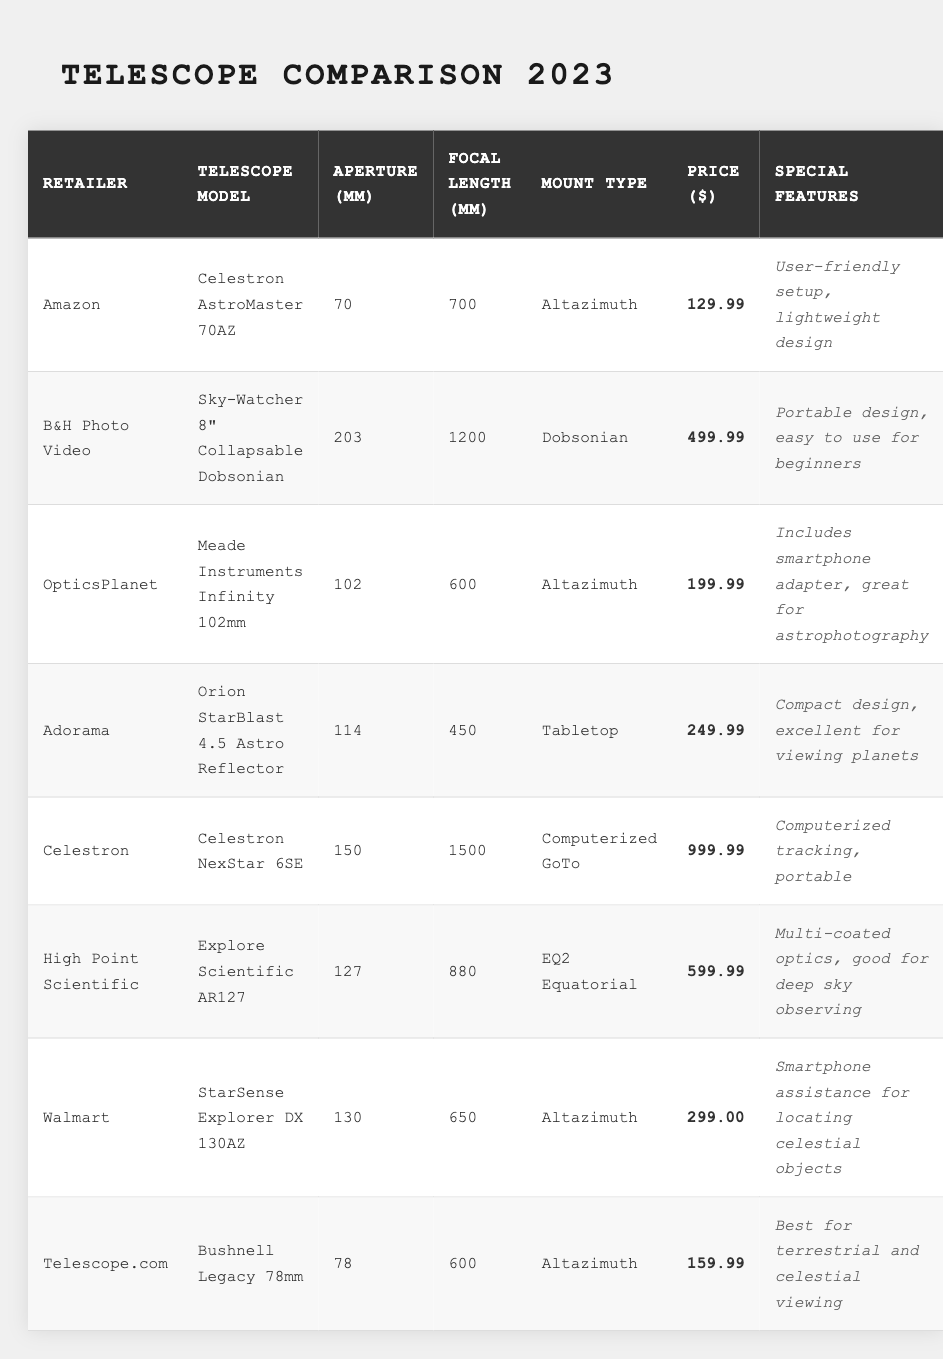What is the most expensive telescope listed in the table? The table indicates that the Celestron NexStar 6SE is priced at $999.99, which is higher than any other telescope listed.
Answer: Celestron NexStar 6SE Which retailer offers the telescope with the largest aperture? The largest aperture listed is 203 mm for the Sky-Watcher 8” Collapsable Dobsonian, which is found at B&H Photo Video.
Answer: B&H Photo Video How many telescopes have a focal length of 600 mm? There are three telescopes with a focal length of 600 mm: Meade Instruments Infinity 102mm from OpticsPlanet, Bushnell Legacy 78mm from Telescope.com, and StarSense Explorer DX 130AZ from Walmart.
Answer: Three Is there any telescope in the table that is specifically recommended for astrophotography? Yes, the Meade Instruments Infinity 102mm is noted for including a smartphone adapter, which is great for astrophotography.
Answer: Yes What is the average price of the telescopes listed in the table? To find the average price, first add the prices: 129.99 + 499.99 + 199.99 + 249.99 + 999.99 + 599.99 + 299.00 + 159.99 = 2130.93. Then divide by the number of telescopes (8), which results in approximately 266.36.
Answer: 266.36 How does the price of the most affordable telescope compare to the most expensive one? The most affordable telescope is the Celestron AstroMaster 70AZ at $129.99, while the most expensive, the Celestron NexStar 6SE, is $999.99. The difference is 999.99 - 129.99 = 870.00.
Answer: 870.00 Which mount type appears the most frequently among the telescopes listed? The Altazimuth mount type appears four times in the table: for Celestron AstroMaster 70AZ, Meade Instruments Infinity 102mm, StarSense Explorer DX 130AZ, and Bushnell Legacy 78mm.
Answer: Altazimuth Are there any telescopes specifically highlighted for beginners? Yes, the Sky-Watcher 8” Collapsable Dobsonian is mentioned as easy to use for beginners.
Answer: Yes What special feature is associated with the telescope from Walmart? The StarSense Explorer DX 130AZ from Walmart features smartphone assistance for locating celestial objects, which is noted in the table.
Answer: Smartphone assistance How many telescopes are mounted in a computerized fashion? Only one telescope, the Celestron NexStar 6SE, has a Computerized GoTo mount type as indicated in the table.
Answer: One 